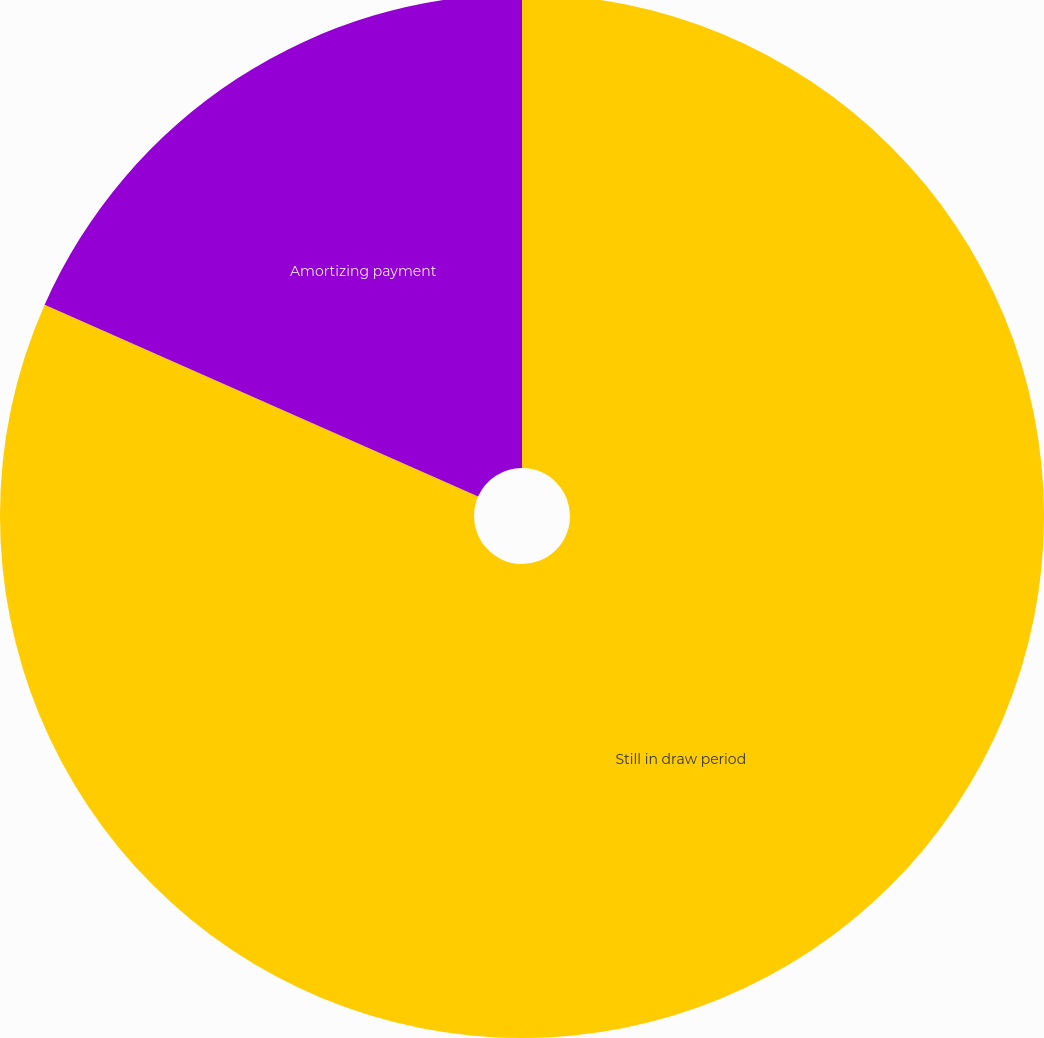<chart> <loc_0><loc_0><loc_500><loc_500><pie_chart><fcel>Still in draw period<fcel>Amortizing payment<nl><fcel>81.63%<fcel>18.37%<nl></chart> 